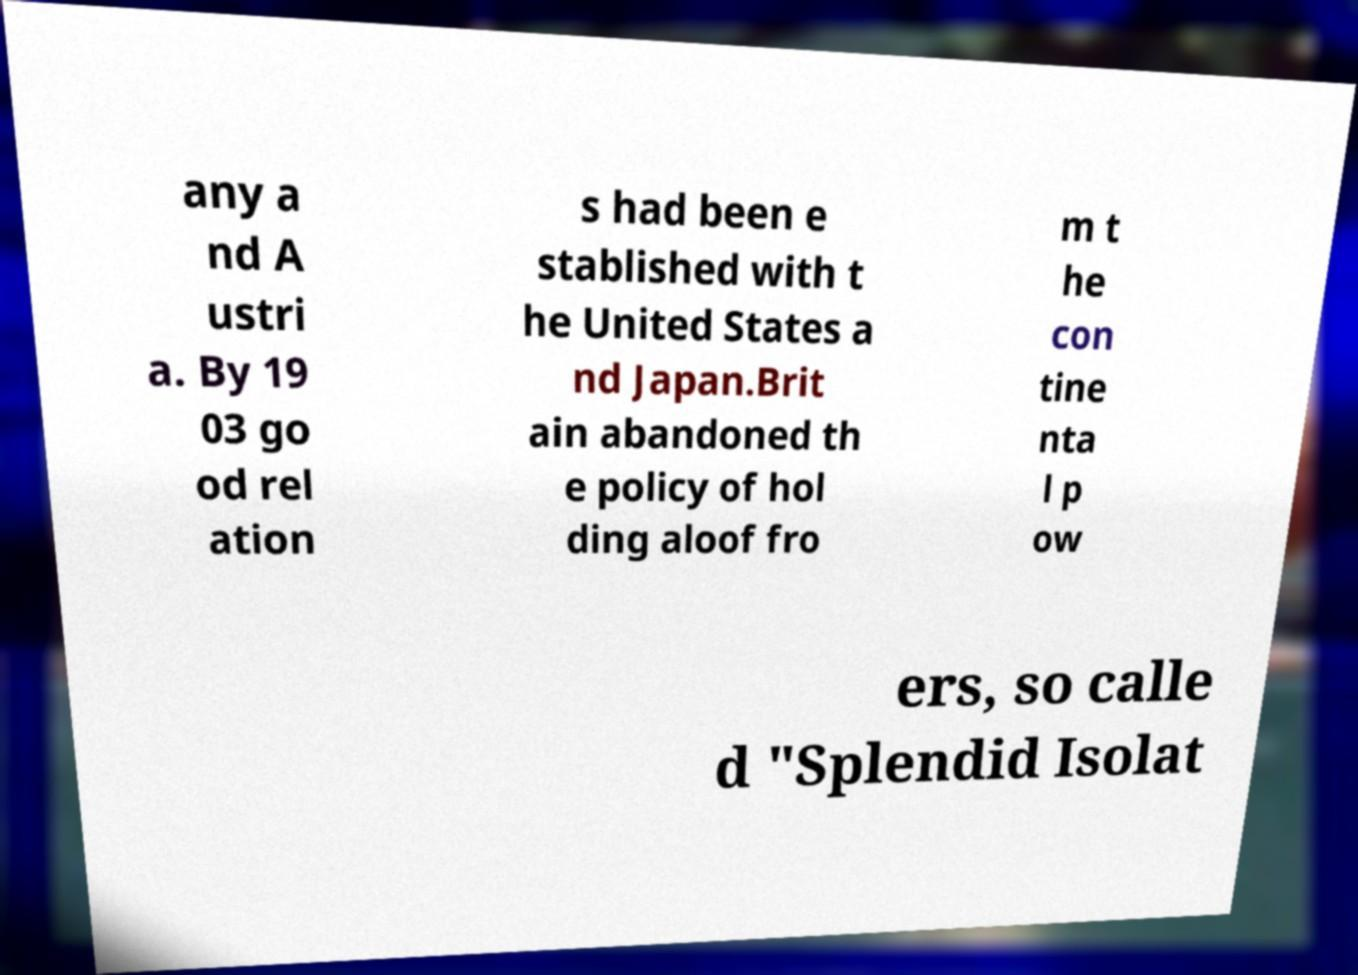What messages or text are displayed in this image? I need them in a readable, typed format. any a nd A ustri a. By 19 03 go od rel ation s had been e stablished with t he United States a nd Japan.Brit ain abandoned th e policy of hol ding aloof fro m t he con tine nta l p ow ers, so calle d "Splendid Isolat 